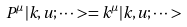<formula> <loc_0><loc_0><loc_500><loc_500>P ^ { \mu } | k , u ; \dots > = k ^ { \mu } | k , u ; \dots ></formula> 